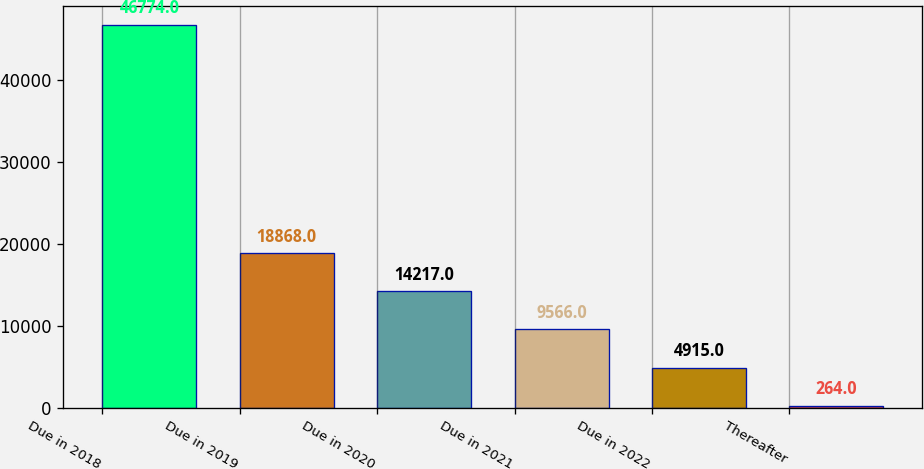Convert chart to OTSL. <chart><loc_0><loc_0><loc_500><loc_500><bar_chart><fcel>Due in 2018<fcel>Due in 2019<fcel>Due in 2020<fcel>Due in 2021<fcel>Due in 2022<fcel>Thereafter<nl><fcel>46774<fcel>18868<fcel>14217<fcel>9566<fcel>4915<fcel>264<nl></chart> 